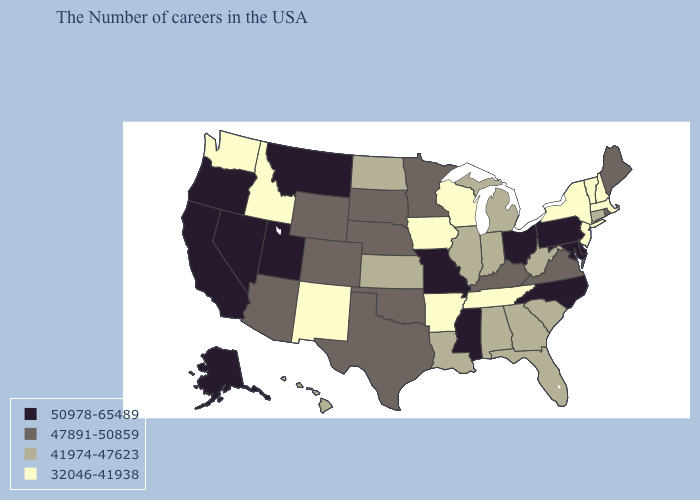What is the highest value in states that border Minnesota?
Keep it brief. 47891-50859. Does Nevada have the highest value in the West?
Short answer required. Yes. How many symbols are there in the legend?
Give a very brief answer. 4. Which states have the lowest value in the West?
Quick response, please. New Mexico, Idaho, Washington. Name the states that have a value in the range 41974-47623?
Short answer required. Connecticut, South Carolina, West Virginia, Florida, Georgia, Michigan, Indiana, Alabama, Illinois, Louisiana, Kansas, North Dakota, Hawaii. What is the value of Rhode Island?
Answer briefly. 47891-50859. Name the states that have a value in the range 41974-47623?
Be succinct. Connecticut, South Carolina, West Virginia, Florida, Georgia, Michigan, Indiana, Alabama, Illinois, Louisiana, Kansas, North Dakota, Hawaii. Which states have the lowest value in the West?
Short answer required. New Mexico, Idaho, Washington. What is the highest value in the USA?
Give a very brief answer. 50978-65489. Which states have the lowest value in the USA?
Be succinct. Massachusetts, New Hampshire, Vermont, New York, New Jersey, Tennessee, Wisconsin, Arkansas, Iowa, New Mexico, Idaho, Washington. Among the states that border New York , which have the lowest value?
Concise answer only. Massachusetts, Vermont, New Jersey. Name the states that have a value in the range 32046-41938?
Answer briefly. Massachusetts, New Hampshire, Vermont, New York, New Jersey, Tennessee, Wisconsin, Arkansas, Iowa, New Mexico, Idaho, Washington. Among the states that border Illinois , does Indiana have the highest value?
Concise answer only. No. Which states have the highest value in the USA?
Quick response, please. Delaware, Maryland, Pennsylvania, North Carolina, Ohio, Mississippi, Missouri, Utah, Montana, Nevada, California, Oregon, Alaska. What is the value of Vermont?
Give a very brief answer. 32046-41938. 